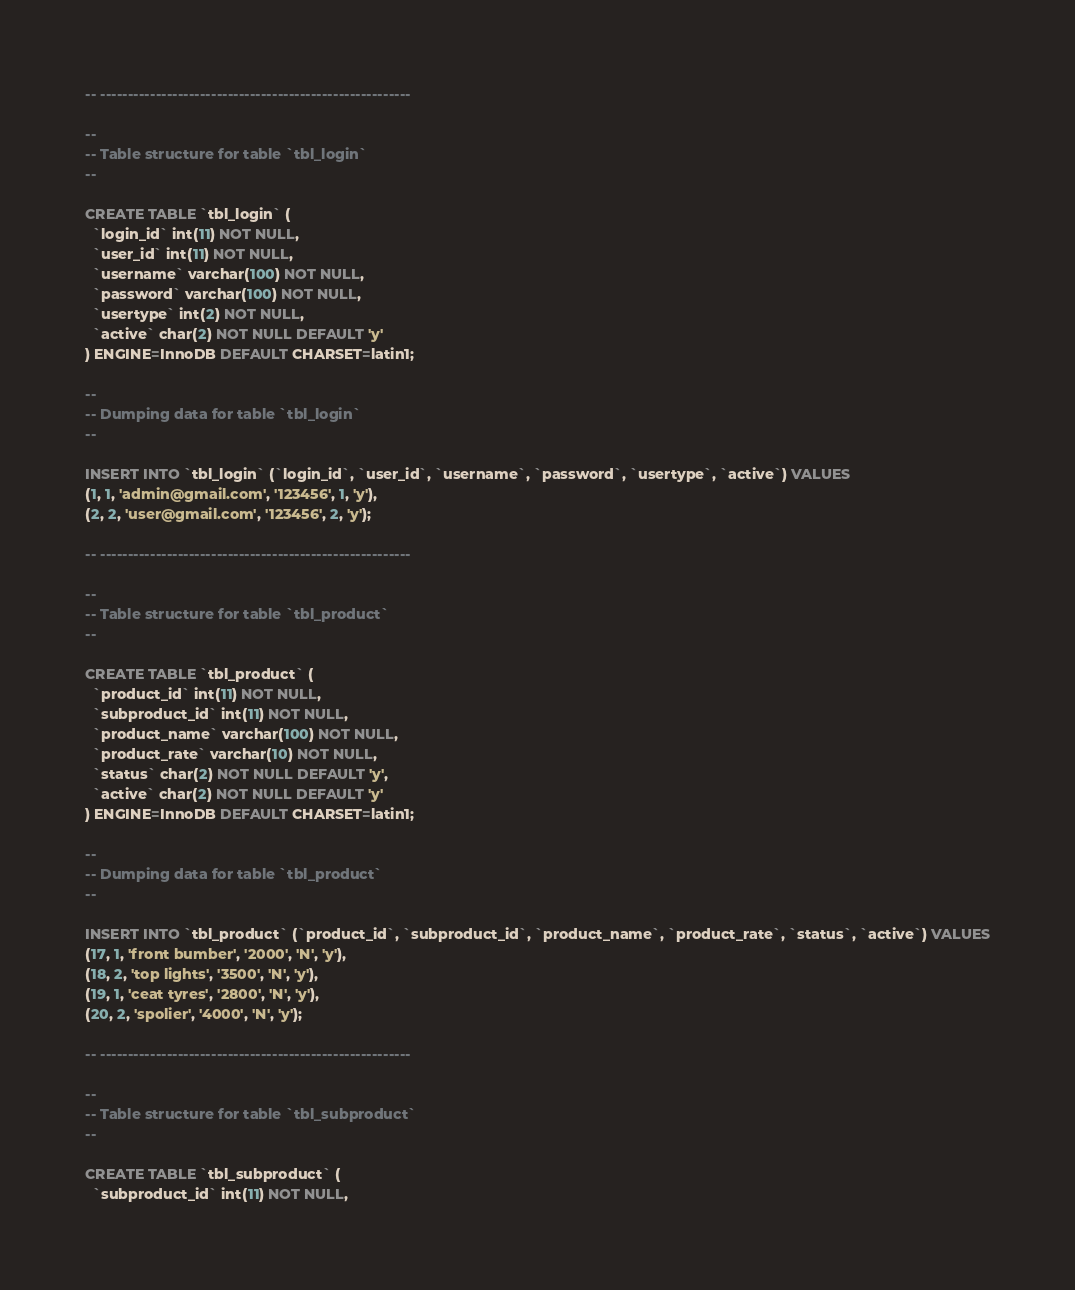<code> <loc_0><loc_0><loc_500><loc_500><_SQL_>-- --------------------------------------------------------

--
-- Table structure for table `tbl_login`
--

CREATE TABLE `tbl_login` (
  `login_id` int(11) NOT NULL,
  `user_id` int(11) NOT NULL,
  `username` varchar(100) NOT NULL,
  `password` varchar(100) NOT NULL,
  `usertype` int(2) NOT NULL,
  `active` char(2) NOT NULL DEFAULT 'y'
) ENGINE=InnoDB DEFAULT CHARSET=latin1;

--
-- Dumping data for table `tbl_login`
--

INSERT INTO `tbl_login` (`login_id`, `user_id`, `username`, `password`, `usertype`, `active`) VALUES
(1, 1, 'admin@gmail.com', '123456', 1, 'y'),
(2, 2, 'user@gmail.com', '123456', 2, 'y');

-- --------------------------------------------------------

--
-- Table structure for table `tbl_product`
--

CREATE TABLE `tbl_product` (
  `product_id` int(11) NOT NULL,
  `subproduct_id` int(11) NOT NULL,
  `product_name` varchar(100) NOT NULL,
  `product_rate` varchar(10) NOT NULL,
  `status` char(2) NOT NULL DEFAULT 'y',
  `active` char(2) NOT NULL DEFAULT 'y'
) ENGINE=InnoDB DEFAULT CHARSET=latin1;

--
-- Dumping data for table `tbl_product`
--

INSERT INTO `tbl_product` (`product_id`, `subproduct_id`, `product_name`, `product_rate`, `status`, `active`) VALUES
(17, 1, 'front bumber', '2000', 'N', 'y'),
(18, 2, 'top lights', '3500', 'N', 'y'),
(19, 1, 'ceat tyres', '2800', 'N', 'y'),
(20, 2, 'spolier', '4000', 'N', 'y');

-- --------------------------------------------------------

--
-- Table structure for table `tbl_subproduct`
--

CREATE TABLE `tbl_subproduct` (
  `subproduct_id` int(11) NOT NULL,</code> 